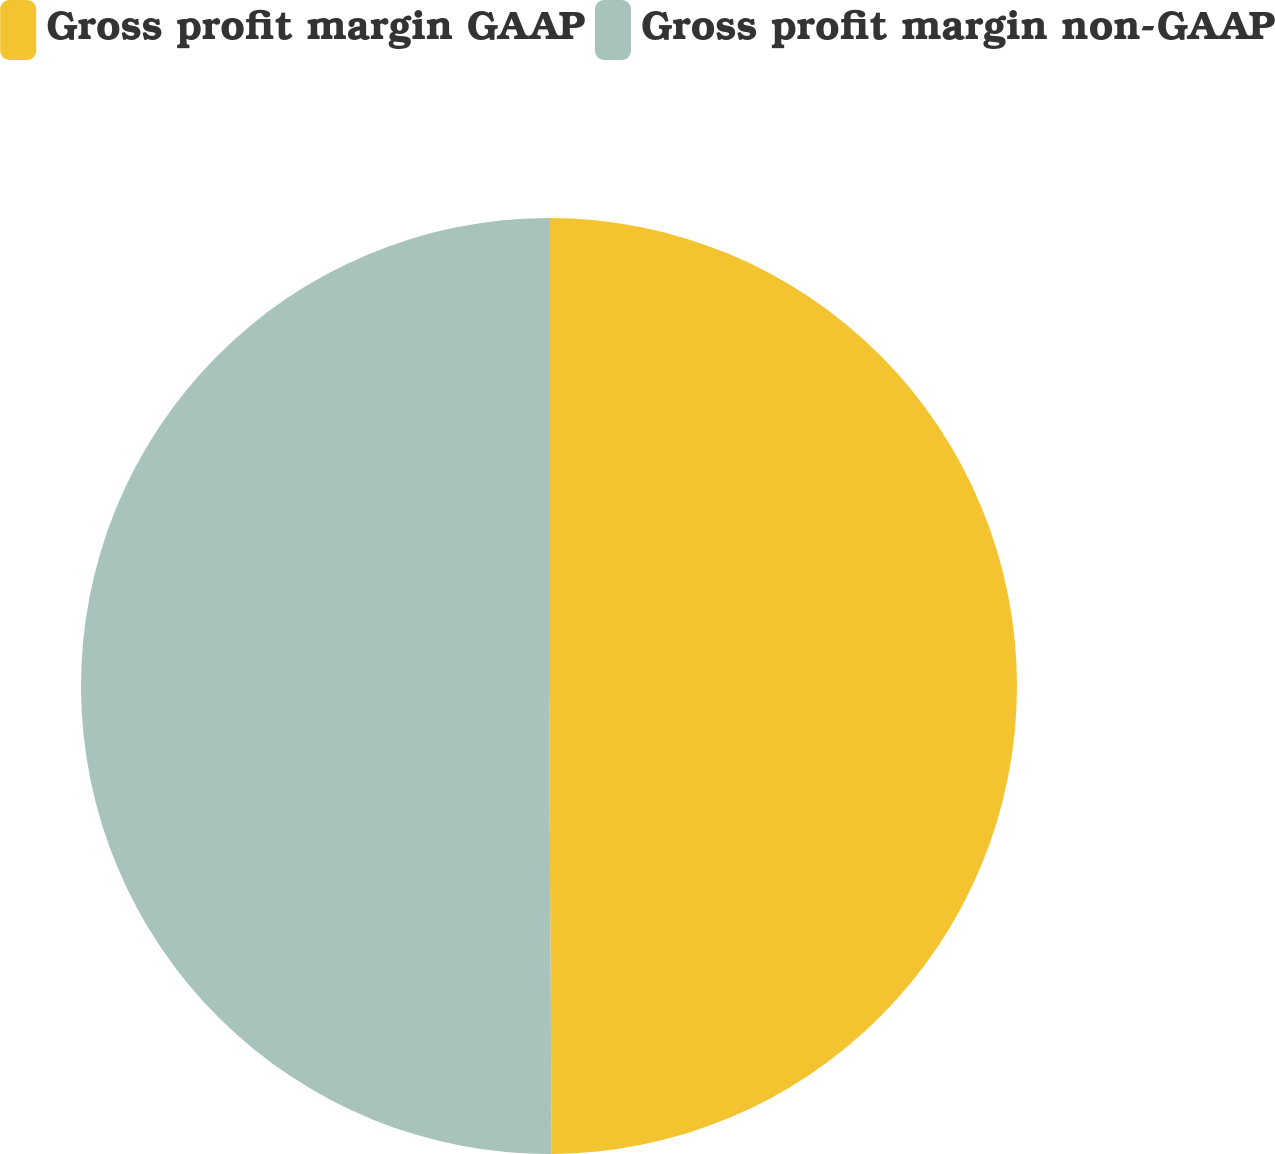Convert chart to OTSL. <chart><loc_0><loc_0><loc_500><loc_500><pie_chart><fcel>Gross profit margin GAAP<fcel>Gross profit margin non-GAAP<nl><fcel>49.91%<fcel>50.09%<nl></chart> 